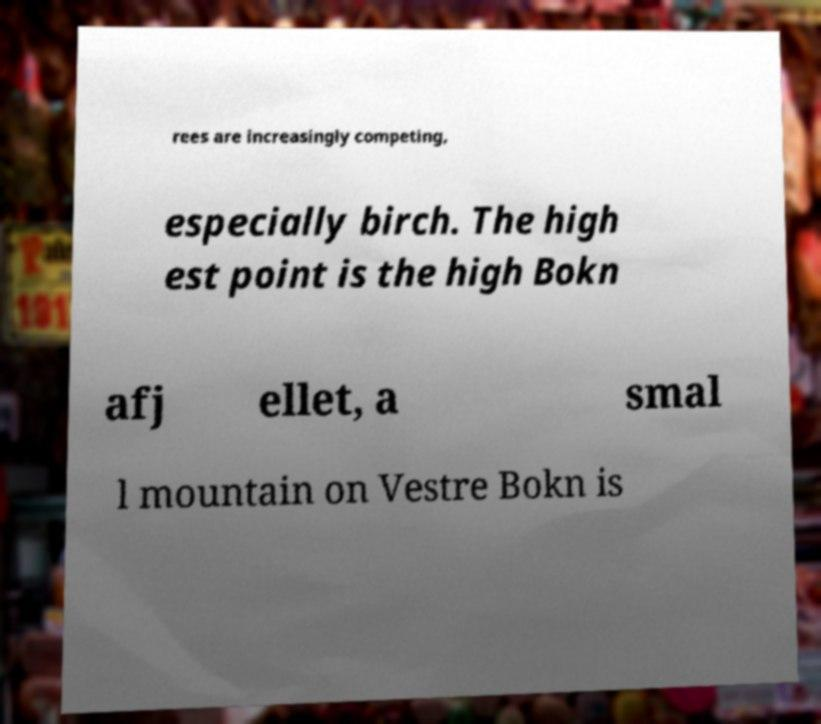Could you assist in decoding the text presented in this image and type it out clearly? rees are increasingly competing, especially birch. The high est point is the high Bokn afj ellet, a smal l mountain on Vestre Bokn is 